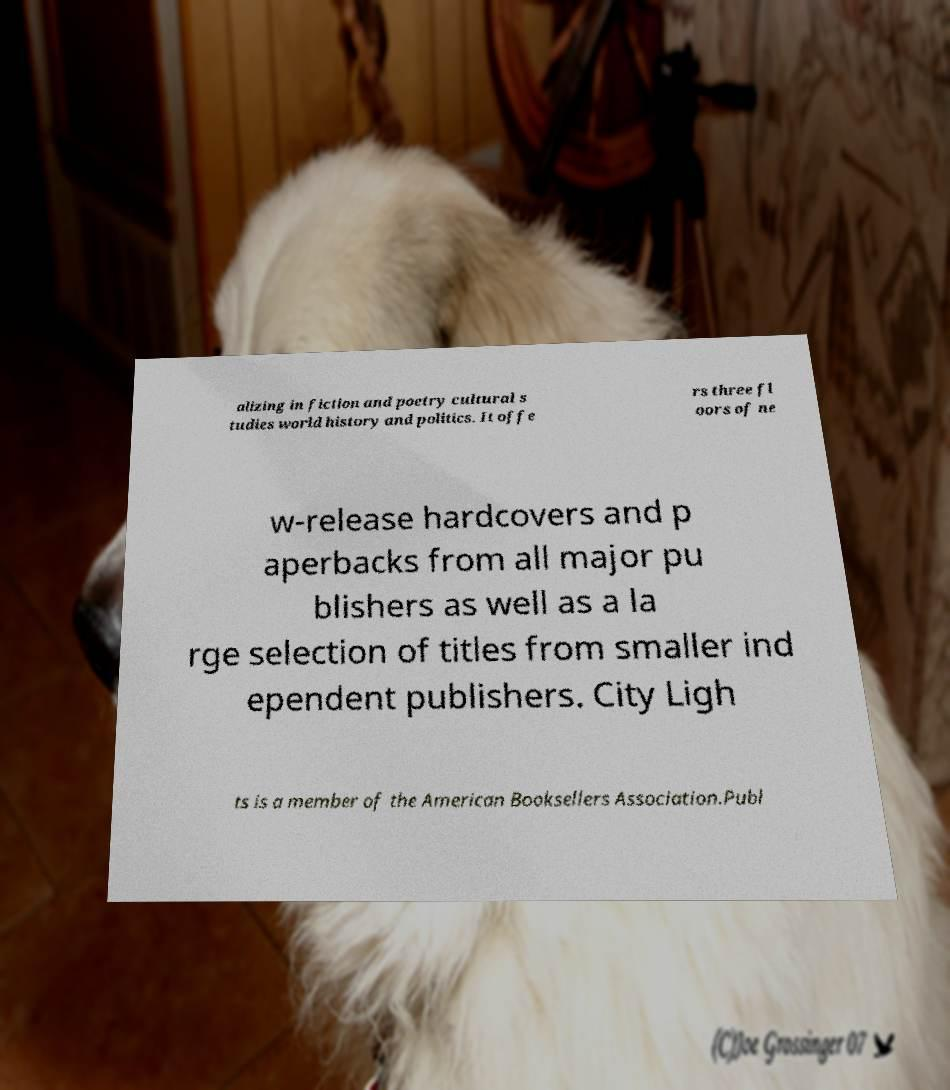Can you read and provide the text displayed in the image?This photo seems to have some interesting text. Can you extract and type it out for me? alizing in fiction and poetry cultural s tudies world history and politics. It offe rs three fl oors of ne w-release hardcovers and p aperbacks from all major pu blishers as well as a la rge selection of titles from smaller ind ependent publishers. City Ligh ts is a member of the American Booksellers Association.Publ 